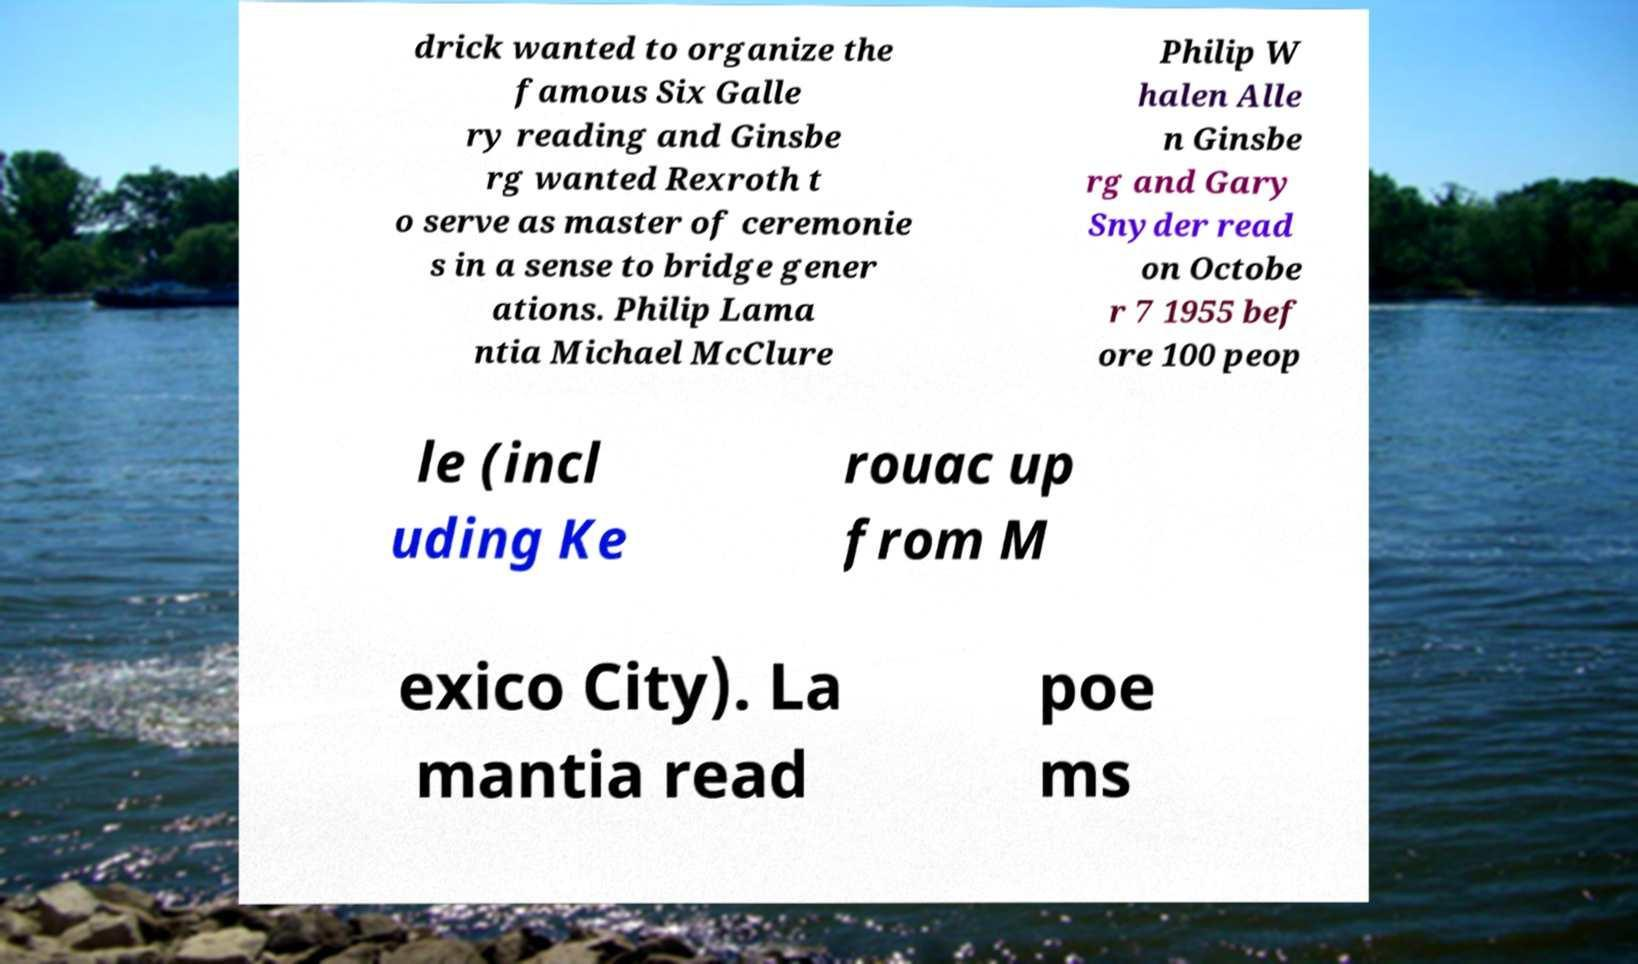There's text embedded in this image that I need extracted. Can you transcribe it verbatim? drick wanted to organize the famous Six Galle ry reading and Ginsbe rg wanted Rexroth t o serve as master of ceremonie s in a sense to bridge gener ations. Philip Lama ntia Michael McClure Philip W halen Alle n Ginsbe rg and Gary Snyder read on Octobe r 7 1955 bef ore 100 peop le (incl uding Ke rouac up from M exico City). La mantia read poe ms 